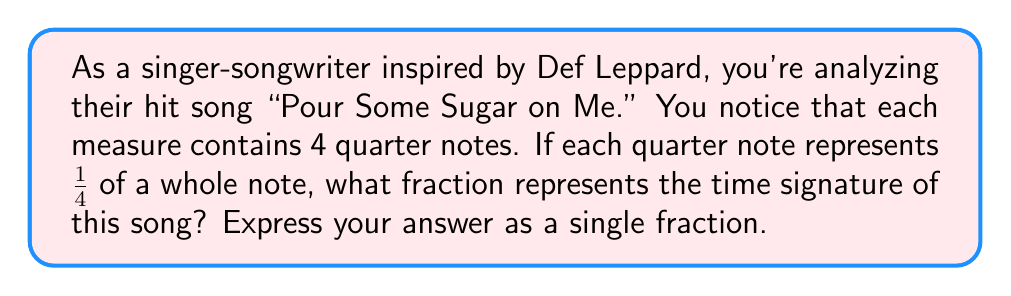Can you solve this math problem? To determine the time signature using fractions, we need to follow these steps:

1. Identify the number of beats per measure:
   In this case, there are 4 quarter notes per measure.

2. Express each beat as a fraction of a whole note:
   Each quarter note is $\frac{1}{4}$ of a whole note.

3. Calculate the total fraction of a whole note in one measure:
   We multiply the number of beats by the fraction each beat represents:
   $$ 4 \times \frac{1}{4} = \frac{4}{4} $$

The resulting fraction $\frac{4}{4}$ represents the time signature of the song. This is commonly known as 4/4 time or "common time" in music notation.

In fraction form, the numerator (4) represents the number of beats per measure, and the denominator (4) indicates that each beat is a quarter note.
Answer: $\frac{4}{4}$ 